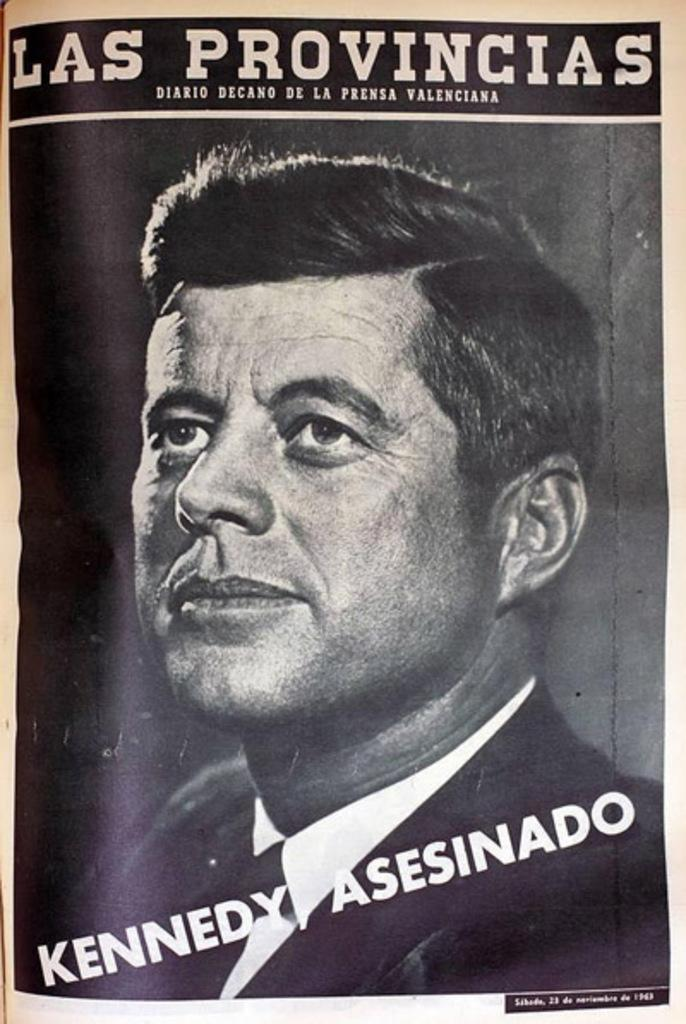<image>
Present a compact description of the photo's key features. A magazine called Las Provincias with the headline Kennedy Asesinado on it. 